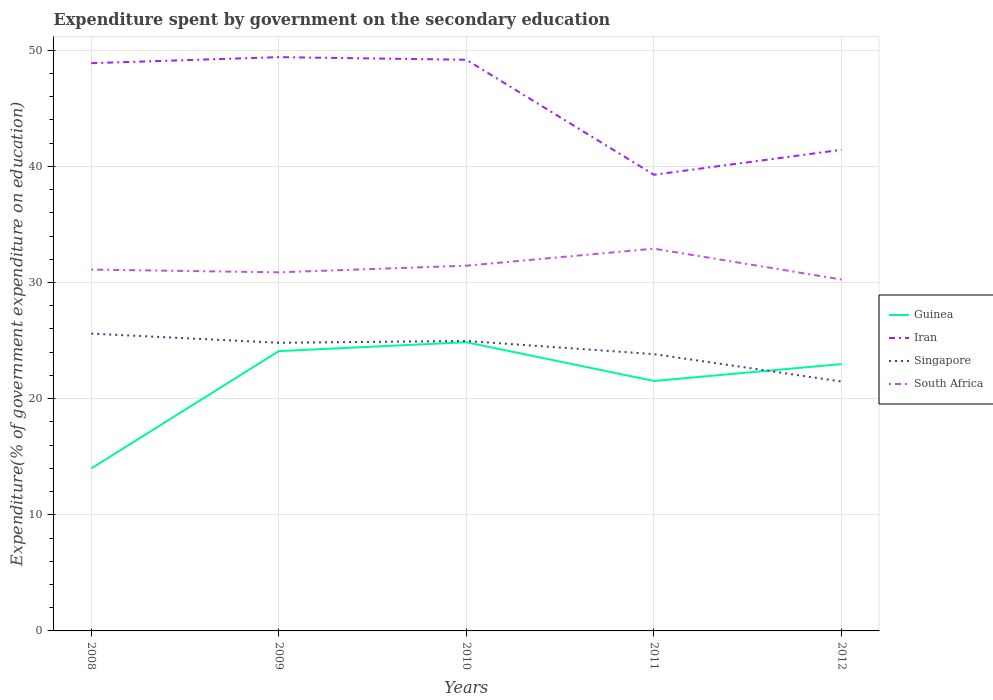How many different coloured lines are there?
Your response must be concise. 4. Across all years, what is the maximum expenditure spent by government on the secondary education in Iran?
Keep it short and to the point. 39.28. What is the total expenditure spent by government on the secondary education in Iran in the graph?
Provide a succinct answer. 0.23. What is the difference between the highest and the second highest expenditure spent by government on the secondary education in South Africa?
Provide a succinct answer. 2.66. What is the difference between the highest and the lowest expenditure spent by government on the secondary education in Guinea?
Provide a succinct answer. 4. Does the graph contain any zero values?
Your answer should be very brief. No. Does the graph contain grids?
Make the answer very short. Yes. Where does the legend appear in the graph?
Ensure brevity in your answer.  Center right. How many legend labels are there?
Offer a very short reply. 4. How are the legend labels stacked?
Give a very brief answer. Vertical. What is the title of the graph?
Offer a terse response. Expenditure spent by government on the secondary education. What is the label or title of the Y-axis?
Provide a short and direct response. Expenditure(% of government expenditure on education). What is the Expenditure(% of government expenditure on education) in Guinea in 2008?
Provide a succinct answer. 13.99. What is the Expenditure(% of government expenditure on education) in Iran in 2008?
Give a very brief answer. 48.89. What is the Expenditure(% of government expenditure on education) in Singapore in 2008?
Offer a terse response. 25.6. What is the Expenditure(% of government expenditure on education) in South Africa in 2008?
Make the answer very short. 31.12. What is the Expenditure(% of government expenditure on education) of Guinea in 2009?
Your answer should be very brief. 24.09. What is the Expenditure(% of government expenditure on education) in Iran in 2009?
Your answer should be very brief. 49.41. What is the Expenditure(% of government expenditure on education) of Singapore in 2009?
Your answer should be very brief. 24.81. What is the Expenditure(% of government expenditure on education) in South Africa in 2009?
Offer a terse response. 30.88. What is the Expenditure(% of government expenditure on education) of Guinea in 2010?
Your answer should be very brief. 24.86. What is the Expenditure(% of government expenditure on education) in Iran in 2010?
Keep it short and to the point. 49.18. What is the Expenditure(% of government expenditure on education) in Singapore in 2010?
Your response must be concise. 24.97. What is the Expenditure(% of government expenditure on education) of South Africa in 2010?
Ensure brevity in your answer.  31.45. What is the Expenditure(% of government expenditure on education) in Guinea in 2011?
Offer a terse response. 21.52. What is the Expenditure(% of government expenditure on education) of Iran in 2011?
Give a very brief answer. 39.28. What is the Expenditure(% of government expenditure on education) in Singapore in 2011?
Ensure brevity in your answer.  23.83. What is the Expenditure(% of government expenditure on education) in South Africa in 2011?
Give a very brief answer. 32.92. What is the Expenditure(% of government expenditure on education) of Guinea in 2012?
Your response must be concise. 22.98. What is the Expenditure(% of government expenditure on education) of Iran in 2012?
Offer a very short reply. 41.43. What is the Expenditure(% of government expenditure on education) of Singapore in 2012?
Ensure brevity in your answer.  21.47. What is the Expenditure(% of government expenditure on education) of South Africa in 2012?
Your answer should be compact. 30.26. Across all years, what is the maximum Expenditure(% of government expenditure on education) of Guinea?
Make the answer very short. 24.86. Across all years, what is the maximum Expenditure(% of government expenditure on education) in Iran?
Offer a terse response. 49.41. Across all years, what is the maximum Expenditure(% of government expenditure on education) in Singapore?
Keep it short and to the point. 25.6. Across all years, what is the maximum Expenditure(% of government expenditure on education) in South Africa?
Provide a succinct answer. 32.92. Across all years, what is the minimum Expenditure(% of government expenditure on education) in Guinea?
Provide a succinct answer. 13.99. Across all years, what is the minimum Expenditure(% of government expenditure on education) in Iran?
Provide a short and direct response. 39.28. Across all years, what is the minimum Expenditure(% of government expenditure on education) of Singapore?
Your response must be concise. 21.47. Across all years, what is the minimum Expenditure(% of government expenditure on education) of South Africa?
Your answer should be very brief. 30.26. What is the total Expenditure(% of government expenditure on education) of Guinea in the graph?
Provide a short and direct response. 107.44. What is the total Expenditure(% of government expenditure on education) in Iran in the graph?
Provide a succinct answer. 228.18. What is the total Expenditure(% of government expenditure on education) of Singapore in the graph?
Give a very brief answer. 120.69. What is the total Expenditure(% of government expenditure on education) in South Africa in the graph?
Ensure brevity in your answer.  156.62. What is the difference between the Expenditure(% of government expenditure on education) of Guinea in 2008 and that in 2009?
Your answer should be very brief. -10.1. What is the difference between the Expenditure(% of government expenditure on education) in Iran in 2008 and that in 2009?
Ensure brevity in your answer.  -0.52. What is the difference between the Expenditure(% of government expenditure on education) in Singapore in 2008 and that in 2009?
Offer a very short reply. 0.79. What is the difference between the Expenditure(% of government expenditure on education) in South Africa in 2008 and that in 2009?
Your answer should be very brief. 0.24. What is the difference between the Expenditure(% of government expenditure on education) of Guinea in 2008 and that in 2010?
Keep it short and to the point. -10.87. What is the difference between the Expenditure(% of government expenditure on education) of Iran in 2008 and that in 2010?
Make the answer very short. -0.3. What is the difference between the Expenditure(% of government expenditure on education) in Singapore in 2008 and that in 2010?
Give a very brief answer. 0.63. What is the difference between the Expenditure(% of government expenditure on education) of South Africa in 2008 and that in 2010?
Offer a very short reply. -0.33. What is the difference between the Expenditure(% of government expenditure on education) in Guinea in 2008 and that in 2011?
Your answer should be very brief. -7.53. What is the difference between the Expenditure(% of government expenditure on education) in Iran in 2008 and that in 2011?
Your answer should be very brief. 9.61. What is the difference between the Expenditure(% of government expenditure on education) of Singapore in 2008 and that in 2011?
Make the answer very short. 1.77. What is the difference between the Expenditure(% of government expenditure on education) in South Africa in 2008 and that in 2011?
Your response must be concise. -1.8. What is the difference between the Expenditure(% of government expenditure on education) of Guinea in 2008 and that in 2012?
Your answer should be compact. -8.99. What is the difference between the Expenditure(% of government expenditure on education) in Iran in 2008 and that in 2012?
Provide a short and direct response. 7.46. What is the difference between the Expenditure(% of government expenditure on education) of Singapore in 2008 and that in 2012?
Make the answer very short. 4.13. What is the difference between the Expenditure(% of government expenditure on education) in South Africa in 2008 and that in 2012?
Your response must be concise. 0.86. What is the difference between the Expenditure(% of government expenditure on education) of Guinea in 2009 and that in 2010?
Make the answer very short. -0.76. What is the difference between the Expenditure(% of government expenditure on education) of Iran in 2009 and that in 2010?
Provide a short and direct response. 0.23. What is the difference between the Expenditure(% of government expenditure on education) of Singapore in 2009 and that in 2010?
Ensure brevity in your answer.  -0.16. What is the difference between the Expenditure(% of government expenditure on education) in South Africa in 2009 and that in 2010?
Make the answer very short. -0.57. What is the difference between the Expenditure(% of government expenditure on education) in Guinea in 2009 and that in 2011?
Provide a short and direct response. 2.57. What is the difference between the Expenditure(% of government expenditure on education) in Iran in 2009 and that in 2011?
Provide a succinct answer. 10.13. What is the difference between the Expenditure(% of government expenditure on education) of Singapore in 2009 and that in 2011?
Keep it short and to the point. 0.98. What is the difference between the Expenditure(% of government expenditure on education) of South Africa in 2009 and that in 2011?
Ensure brevity in your answer.  -2.04. What is the difference between the Expenditure(% of government expenditure on education) in Guinea in 2009 and that in 2012?
Offer a very short reply. 1.12. What is the difference between the Expenditure(% of government expenditure on education) in Iran in 2009 and that in 2012?
Provide a succinct answer. 7.98. What is the difference between the Expenditure(% of government expenditure on education) of Singapore in 2009 and that in 2012?
Your answer should be compact. 3.34. What is the difference between the Expenditure(% of government expenditure on education) in South Africa in 2009 and that in 2012?
Your answer should be very brief. 0.62. What is the difference between the Expenditure(% of government expenditure on education) in Guinea in 2010 and that in 2011?
Ensure brevity in your answer.  3.33. What is the difference between the Expenditure(% of government expenditure on education) in Iran in 2010 and that in 2011?
Offer a very short reply. 9.9. What is the difference between the Expenditure(% of government expenditure on education) of Singapore in 2010 and that in 2011?
Your answer should be compact. 1.13. What is the difference between the Expenditure(% of government expenditure on education) of South Africa in 2010 and that in 2011?
Provide a short and direct response. -1.47. What is the difference between the Expenditure(% of government expenditure on education) of Guinea in 2010 and that in 2012?
Ensure brevity in your answer.  1.88. What is the difference between the Expenditure(% of government expenditure on education) of Iran in 2010 and that in 2012?
Your answer should be very brief. 7.75. What is the difference between the Expenditure(% of government expenditure on education) of Singapore in 2010 and that in 2012?
Offer a terse response. 3.49. What is the difference between the Expenditure(% of government expenditure on education) of South Africa in 2010 and that in 2012?
Ensure brevity in your answer.  1.19. What is the difference between the Expenditure(% of government expenditure on education) in Guinea in 2011 and that in 2012?
Give a very brief answer. -1.45. What is the difference between the Expenditure(% of government expenditure on education) in Iran in 2011 and that in 2012?
Give a very brief answer. -2.15. What is the difference between the Expenditure(% of government expenditure on education) in Singapore in 2011 and that in 2012?
Ensure brevity in your answer.  2.36. What is the difference between the Expenditure(% of government expenditure on education) of South Africa in 2011 and that in 2012?
Offer a very short reply. 2.66. What is the difference between the Expenditure(% of government expenditure on education) of Guinea in 2008 and the Expenditure(% of government expenditure on education) of Iran in 2009?
Provide a short and direct response. -35.42. What is the difference between the Expenditure(% of government expenditure on education) in Guinea in 2008 and the Expenditure(% of government expenditure on education) in Singapore in 2009?
Give a very brief answer. -10.82. What is the difference between the Expenditure(% of government expenditure on education) in Guinea in 2008 and the Expenditure(% of government expenditure on education) in South Africa in 2009?
Give a very brief answer. -16.89. What is the difference between the Expenditure(% of government expenditure on education) in Iran in 2008 and the Expenditure(% of government expenditure on education) in Singapore in 2009?
Your answer should be compact. 24.07. What is the difference between the Expenditure(% of government expenditure on education) in Iran in 2008 and the Expenditure(% of government expenditure on education) in South Africa in 2009?
Provide a short and direct response. 18.01. What is the difference between the Expenditure(% of government expenditure on education) of Singapore in 2008 and the Expenditure(% of government expenditure on education) of South Africa in 2009?
Keep it short and to the point. -5.28. What is the difference between the Expenditure(% of government expenditure on education) in Guinea in 2008 and the Expenditure(% of government expenditure on education) in Iran in 2010?
Your answer should be compact. -35.19. What is the difference between the Expenditure(% of government expenditure on education) in Guinea in 2008 and the Expenditure(% of government expenditure on education) in Singapore in 2010?
Provide a succinct answer. -10.98. What is the difference between the Expenditure(% of government expenditure on education) in Guinea in 2008 and the Expenditure(% of government expenditure on education) in South Africa in 2010?
Offer a terse response. -17.46. What is the difference between the Expenditure(% of government expenditure on education) of Iran in 2008 and the Expenditure(% of government expenditure on education) of Singapore in 2010?
Offer a very short reply. 23.92. What is the difference between the Expenditure(% of government expenditure on education) of Iran in 2008 and the Expenditure(% of government expenditure on education) of South Africa in 2010?
Ensure brevity in your answer.  17.44. What is the difference between the Expenditure(% of government expenditure on education) of Singapore in 2008 and the Expenditure(% of government expenditure on education) of South Africa in 2010?
Your answer should be very brief. -5.85. What is the difference between the Expenditure(% of government expenditure on education) in Guinea in 2008 and the Expenditure(% of government expenditure on education) in Iran in 2011?
Offer a very short reply. -25.29. What is the difference between the Expenditure(% of government expenditure on education) of Guinea in 2008 and the Expenditure(% of government expenditure on education) of Singapore in 2011?
Provide a succinct answer. -9.84. What is the difference between the Expenditure(% of government expenditure on education) in Guinea in 2008 and the Expenditure(% of government expenditure on education) in South Africa in 2011?
Make the answer very short. -18.93. What is the difference between the Expenditure(% of government expenditure on education) in Iran in 2008 and the Expenditure(% of government expenditure on education) in Singapore in 2011?
Your response must be concise. 25.05. What is the difference between the Expenditure(% of government expenditure on education) in Iran in 2008 and the Expenditure(% of government expenditure on education) in South Africa in 2011?
Offer a very short reply. 15.97. What is the difference between the Expenditure(% of government expenditure on education) in Singapore in 2008 and the Expenditure(% of government expenditure on education) in South Africa in 2011?
Ensure brevity in your answer.  -7.32. What is the difference between the Expenditure(% of government expenditure on education) of Guinea in 2008 and the Expenditure(% of government expenditure on education) of Iran in 2012?
Keep it short and to the point. -27.44. What is the difference between the Expenditure(% of government expenditure on education) in Guinea in 2008 and the Expenditure(% of government expenditure on education) in Singapore in 2012?
Keep it short and to the point. -7.48. What is the difference between the Expenditure(% of government expenditure on education) in Guinea in 2008 and the Expenditure(% of government expenditure on education) in South Africa in 2012?
Provide a succinct answer. -16.27. What is the difference between the Expenditure(% of government expenditure on education) of Iran in 2008 and the Expenditure(% of government expenditure on education) of Singapore in 2012?
Your answer should be compact. 27.41. What is the difference between the Expenditure(% of government expenditure on education) in Iran in 2008 and the Expenditure(% of government expenditure on education) in South Africa in 2012?
Make the answer very short. 18.63. What is the difference between the Expenditure(% of government expenditure on education) of Singapore in 2008 and the Expenditure(% of government expenditure on education) of South Africa in 2012?
Your answer should be compact. -4.66. What is the difference between the Expenditure(% of government expenditure on education) in Guinea in 2009 and the Expenditure(% of government expenditure on education) in Iran in 2010?
Provide a succinct answer. -25.09. What is the difference between the Expenditure(% of government expenditure on education) in Guinea in 2009 and the Expenditure(% of government expenditure on education) in Singapore in 2010?
Give a very brief answer. -0.87. What is the difference between the Expenditure(% of government expenditure on education) of Guinea in 2009 and the Expenditure(% of government expenditure on education) of South Africa in 2010?
Your answer should be very brief. -7.36. What is the difference between the Expenditure(% of government expenditure on education) of Iran in 2009 and the Expenditure(% of government expenditure on education) of Singapore in 2010?
Your answer should be compact. 24.44. What is the difference between the Expenditure(% of government expenditure on education) of Iran in 2009 and the Expenditure(% of government expenditure on education) of South Africa in 2010?
Offer a very short reply. 17.96. What is the difference between the Expenditure(% of government expenditure on education) of Singapore in 2009 and the Expenditure(% of government expenditure on education) of South Africa in 2010?
Your response must be concise. -6.64. What is the difference between the Expenditure(% of government expenditure on education) of Guinea in 2009 and the Expenditure(% of government expenditure on education) of Iran in 2011?
Provide a succinct answer. -15.18. What is the difference between the Expenditure(% of government expenditure on education) of Guinea in 2009 and the Expenditure(% of government expenditure on education) of Singapore in 2011?
Your answer should be compact. 0.26. What is the difference between the Expenditure(% of government expenditure on education) of Guinea in 2009 and the Expenditure(% of government expenditure on education) of South Africa in 2011?
Give a very brief answer. -8.82. What is the difference between the Expenditure(% of government expenditure on education) in Iran in 2009 and the Expenditure(% of government expenditure on education) in Singapore in 2011?
Offer a very short reply. 25.57. What is the difference between the Expenditure(% of government expenditure on education) in Iran in 2009 and the Expenditure(% of government expenditure on education) in South Africa in 2011?
Your response must be concise. 16.49. What is the difference between the Expenditure(% of government expenditure on education) of Singapore in 2009 and the Expenditure(% of government expenditure on education) of South Africa in 2011?
Make the answer very short. -8.1. What is the difference between the Expenditure(% of government expenditure on education) in Guinea in 2009 and the Expenditure(% of government expenditure on education) in Iran in 2012?
Provide a succinct answer. -17.33. What is the difference between the Expenditure(% of government expenditure on education) of Guinea in 2009 and the Expenditure(% of government expenditure on education) of Singapore in 2012?
Ensure brevity in your answer.  2.62. What is the difference between the Expenditure(% of government expenditure on education) of Guinea in 2009 and the Expenditure(% of government expenditure on education) of South Africa in 2012?
Ensure brevity in your answer.  -6.16. What is the difference between the Expenditure(% of government expenditure on education) in Iran in 2009 and the Expenditure(% of government expenditure on education) in Singapore in 2012?
Make the answer very short. 27.93. What is the difference between the Expenditure(% of government expenditure on education) in Iran in 2009 and the Expenditure(% of government expenditure on education) in South Africa in 2012?
Provide a short and direct response. 19.15. What is the difference between the Expenditure(% of government expenditure on education) in Singapore in 2009 and the Expenditure(% of government expenditure on education) in South Africa in 2012?
Make the answer very short. -5.44. What is the difference between the Expenditure(% of government expenditure on education) in Guinea in 2010 and the Expenditure(% of government expenditure on education) in Iran in 2011?
Offer a very short reply. -14.42. What is the difference between the Expenditure(% of government expenditure on education) of Guinea in 2010 and the Expenditure(% of government expenditure on education) of Singapore in 2011?
Ensure brevity in your answer.  1.02. What is the difference between the Expenditure(% of government expenditure on education) in Guinea in 2010 and the Expenditure(% of government expenditure on education) in South Africa in 2011?
Your answer should be very brief. -8.06. What is the difference between the Expenditure(% of government expenditure on education) in Iran in 2010 and the Expenditure(% of government expenditure on education) in Singapore in 2011?
Make the answer very short. 25.35. What is the difference between the Expenditure(% of government expenditure on education) in Iran in 2010 and the Expenditure(% of government expenditure on education) in South Africa in 2011?
Your answer should be compact. 16.27. What is the difference between the Expenditure(% of government expenditure on education) in Singapore in 2010 and the Expenditure(% of government expenditure on education) in South Africa in 2011?
Offer a terse response. -7.95. What is the difference between the Expenditure(% of government expenditure on education) of Guinea in 2010 and the Expenditure(% of government expenditure on education) of Iran in 2012?
Ensure brevity in your answer.  -16.57. What is the difference between the Expenditure(% of government expenditure on education) in Guinea in 2010 and the Expenditure(% of government expenditure on education) in Singapore in 2012?
Keep it short and to the point. 3.38. What is the difference between the Expenditure(% of government expenditure on education) in Guinea in 2010 and the Expenditure(% of government expenditure on education) in South Africa in 2012?
Ensure brevity in your answer.  -5.4. What is the difference between the Expenditure(% of government expenditure on education) of Iran in 2010 and the Expenditure(% of government expenditure on education) of Singapore in 2012?
Give a very brief answer. 27.71. What is the difference between the Expenditure(% of government expenditure on education) of Iran in 2010 and the Expenditure(% of government expenditure on education) of South Africa in 2012?
Keep it short and to the point. 18.93. What is the difference between the Expenditure(% of government expenditure on education) of Singapore in 2010 and the Expenditure(% of government expenditure on education) of South Africa in 2012?
Provide a short and direct response. -5.29. What is the difference between the Expenditure(% of government expenditure on education) of Guinea in 2011 and the Expenditure(% of government expenditure on education) of Iran in 2012?
Ensure brevity in your answer.  -19.9. What is the difference between the Expenditure(% of government expenditure on education) of Guinea in 2011 and the Expenditure(% of government expenditure on education) of Singapore in 2012?
Ensure brevity in your answer.  0.05. What is the difference between the Expenditure(% of government expenditure on education) in Guinea in 2011 and the Expenditure(% of government expenditure on education) in South Africa in 2012?
Offer a very short reply. -8.73. What is the difference between the Expenditure(% of government expenditure on education) of Iran in 2011 and the Expenditure(% of government expenditure on education) of Singapore in 2012?
Your answer should be very brief. 17.81. What is the difference between the Expenditure(% of government expenditure on education) in Iran in 2011 and the Expenditure(% of government expenditure on education) in South Africa in 2012?
Your answer should be compact. 9.02. What is the difference between the Expenditure(% of government expenditure on education) of Singapore in 2011 and the Expenditure(% of government expenditure on education) of South Africa in 2012?
Your answer should be very brief. -6.42. What is the average Expenditure(% of government expenditure on education) in Guinea per year?
Offer a terse response. 21.49. What is the average Expenditure(% of government expenditure on education) of Iran per year?
Your response must be concise. 45.64. What is the average Expenditure(% of government expenditure on education) in Singapore per year?
Make the answer very short. 24.14. What is the average Expenditure(% of government expenditure on education) of South Africa per year?
Give a very brief answer. 31.32. In the year 2008, what is the difference between the Expenditure(% of government expenditure on education) of Guinea and Expenditure(% of government expenditure on education) of Iran?
Your answer should be very brief. -34.9. In the year 2008, what is the difference between the Expenditure(% of government expenditure on education) in Guinea and Expenditure(% of government expenditure on education) in Singapore?
Keep it short and to the point. -11.61. In the year 2008, what is the difference between the Expenditure(% of government expenditure on education) in Guinea and Expenditure(% of government expenditure on education) in South Africa?
Make the answer very short. -17.13. In the year 2008, what is the difference between the Expenditure(% of government expenditure on education) of Iran and Expenditure(% of government expenditure on education) of Singapore?
Offer a very short reply. 23.29. In the year 2008, what is the difference between the Expenditure(% of government expenditure on education) in Iran and Expenditure(% of government expenditure on education) in South Africa?
Make the answer very short. 17.77. In the year 2008, what is the difference between the Expenditure(% of government expenditure on education) in Singapore and Expenditure(% of government expenditure on education) in South Africa?
Ensure brevity in your answer.  -5.52. In the year 2009, what is the difference between the Expenditure(% of government expenditure on education) in Guinea and Expenditure(% of government expenditure on education) in Iran?
Offer a terse response. -25.31. In the year 2009, what is the difference between the Expenditure(% of government expenditure on education) of Guinea and Expenditure(% of government expenditure on education) of Singapore?
Offer a terse response. -0.72. In the year 2009, what is the difference between the Expenditure(% of government expenditure on education) of Guinea and Expenditure(% of government expenditure on education) of South Africa?
Offer a terse response. -6.78. In the year 2009, what is the difference between the Expenditure(% of government expenditure on education) in Iran and Expenditure(% of government expenditure on education) in Singapore?
Your response must be concise. 24.6. In the year 2009, what is the difference between the Expenditure(% of government expenditure on education) in Iran and Expenditure(% of government expenditure on education) in South Africa?
Your answer should be compact. 18.53. In the year 2009, what is the difference between the Expenditure(% of government expenditure on education) of Singapore and Expenditure(% of government expenditure on education) of South Africa?
Ensure brevity in your answer.  -6.07. In the year 2010, what is the difference between the Expenditure(% of government expenditure on education) of Guinea and Expenditure(% of government expenditure on education) of Iran?
Ensure brevity in your answer.  -24.32. In the year 2010, what is the difference between the Expenditure(% of government expenditure on education) of Guinea and Expenditure(% of government expenditure on education) of Singapore?
Offer a very short reply. -0.11. In the year 2010, what is the difference between the Expenditure(% of government expenditure on education) of Guinea and Expenditure(% of government expenditure on education) of South Africa?
Give a very brief answer. -6.59. In the year 2010, what is the difference between the Expenditure(% of government expenditure on education) of Iran and Expenditure(% of government expenditure on education) of Singapore?
Provide a succinct answer. 24.21. In the year 2010, what is the difference between the Expenditure(% of government expenditure on education) of Iran and Expenditure(% of government expenditure on education) of South Africa?
Keep it short and to the point. 17.73. In the year 2010, what is the difference between the Expenditure(% of government expenditure on education) in Singapore and Expenditure(% of government expenditure on education) in South Africa?
Provide a short and direct response. -6.48. In the year 2011, what is the difference between the Expenditure(% of government expenditure on education) of Guinea and Expenditure(% of government expenditure on education) of Iran?
Give a very brief answer. -17.76. In the year 2011, what is the difference between the Expenditure(% of government expenditure on education) in Guinea and Expenditure(% of government expenditure on education) in Singapore?
Offer a very short reply. -2.31. In the year 2011, what is the difference between the Expenditure(% of government expenditure on education) in Guinea and Expenditure(% of government expenditure on education) in South Africa?
Provide a succinct answer. -11.39. In the year 2011, what is the difference between the Expenditure(% of government expenditure on education) in Iran and Expenditure(% of government expenditure on education) in Singapore?
Your answer should be very brief. 15.44. In the year 2011, what is the difference between the Expenditure(% of government expenditure on education) of Iran and Expenditure(% of government expenditure on education) of South Africa?
Your answer should be compact. 6.36. In the year 2011, what is the difference between the Expenditure(% of government expenditure on education) in Singapore and Expenditure(% of government expenditure on education) in South Africa?
Offer a very short reply. -9.08. In the year 2012, what is the difference between the Expenditure(% of government expenditure on education) in Guinea and Expenditure(% of government expenditure on education) in Iran?
Keep it short and to the point. -18.45. In the year 2012, what is the difference between the Expenditure(% of government expenditure on education) in Guinea and Expenditure(% of government expenditure on education) in Singapore?
Give a very brief answer. 1.5. In the year 2012, what is the difference between the Expenditure(% of government expenditure on education) in Guinea and Expenditure(% of government expenditure on education) in South Africa?
Ensure brevity in your answer.  -7.28. In the year 2012, what is the difference between the Expenditure(% of government expenditure on education) of Iran and Expenditure(% of government expenditure on education) of Singapore?
Offer a very short reply. 19.95. In the year 2012, what is the difference between the Expenditure(% of government expenditure on education) in Iran and Expenditure(% of government expenditure on education) in South Africa?
Give a very brief answer. 11.17. In the year 2012, what is the difference between the Expenditure(% of government expenditure on education) of Singapore and Expenditure(% of government expenditure on education) of South Africa?
Offer a terse response. -8.78. What is the ratio of the Expenditure(% of government expenditure on education) in Guinea in 2008 to that in 2009?
Provide a succinct answer. 0.58. What is the ratio of the Expenditure(% of government expenditure on education) in Iran in 2008 to that in 2009?
Provide a succinct answer. 0.99. What is the ratio of the Expenditure(% of government expenditure on education) of Singapore in 2008 to that in 2009?
Provide a short and direct response. 1.03. What is the ratio of the Expenditure(% of government expenditure on education) of South Africa in 2008 to that in 2009?
Provide a succinct answer. 1.01. What is the ratio of the Expenditure(% of government expenditure on education) of Guinea in 2008 to that in 2010?
Ensure brevity in your answer.  0.56. What is the ratio of the Expenditure(% of government expenditure on education) in Singapore in 2008 to that in 2010?
Keep it short and to the point. 1.03. What is the ratio of the Expenditure(% of government expenditure on education) of South Africa in 2008 to that in 2010?
Your answer should be very brief. 0.99. What is the ratio of the Expenditure(% of government expenditure on education) in Guinea in 2008 to that in 2011?
Provide a short and direct response. 0.65. What is the ratio of the Expenditure(% of government expenditure on education) of Iran in 2008 to that in 2011?
Your answer should be very brief. 1.24. What is the ratio of the Expenditure(% of government expenditure on education) in Singapore in 2008 to that in 2011?
Keep it short and to the point. 1.07. What is the ratio of the Expenditure(% of government expenditure on education) in South Africa in 2008 to that in 2011?
Make the answer very short. 0.95. What is the ratio of the Expenditure(% of government expenditure on education) in Guinea in 2008 to that in 2012?
Your answer should be compact. 0.61. What is the ratio of the Expenditure(% of government expenditure on education) of Iran in 2008 to that in 2012?
Your response must be concise. 1.18. What is the ratio of the Expenditure(% of government expenditure on education) in Singapore in 2008 to that in 2012?
Keep it short and to the point. 1.19. What is the ratio of the Expenditure(% of government expenditure on education) of South Africa in 2008 to that in 2012?
Give a very brief answer. 1.03. What is the ratio of the Expenditure(% of government expenditure on education) of Guinea in 2009 to that in 2010?
Provide a short and direct response. 0.97. What is the ratio of the Expenditure(% of government expenditure on education) of Iran in 2009 to that in 2010?
Provide a short and direct response. 1. What is the ratio of the Expenditure(% of government expenditure on education) in South Africa in 2009 to that in 2010?
Your response must be concise. 0.98. What is the ratio of the Expenditure(% of government expenditure on education) in Guinea in 2009 to that in 2011?
Offer a very short reply. 1.12. What is the ratio of the Expenditure(% of government expenditure on education) in Iran in 2009 to that in 2011?
Offer a terse response. 1.26. What is the ratio of the Expenditure(% of government expenditure on education) of Singapore in 2009 to that in 2011?
Provide a succinct answer. 1.04. What is the ratio of the Expenditure(% of government expenditure on education) in South Africa in 2009 to that in 2011?
Ensure brevity in your answer.  0.94. What is the ratio of the Expenditure(% of government expenditure on education) of Guinea in 2009 to that in 2012?
Provide a succinct answer. 1.05. What is the ratio of the Expenditure(% of government expenditure on education) of Iran in 2009 to that in 2012?
Give a very brief answer. 1.19. What is the ratio of the Expenditure(% of government expenditure on education) in Singapore in 2009 to that in 2012?
Provide a short and direct response. 1.16. What is the ratio of the Expenditure(% of government expenditure on education) in South Africa in 2009 to that in 2012?
Provide a short and direct response. 1.02. What is the ratio of the Expenditure(% of government expenditure on education) of Guinea in 2010 to that in 2011?
Ensure brevity in your answer.  1.15. What is the ratio of the Expenditure(% of government expenditure on education) of Iran in 2010 to that in 2011?
Your response must be concise. 1.25. What is the ratio of the Expenditure(% of government expenditure on education) in Singapore in 2010 to that in 2011?
Your answer should be very brief. 1.05. What is the ratio of the Expenditure(% of government expenditure on education) in South Africa in 2010 to that in 2011?
Keep it short and to the point. 0.96. What is the ratio of the Expenditure(% of government expenditure on education) of Guinea in 2010 to that in 2012?
Provide a succinct answer. 1.08. What is the ratio of the Expenditure(% of government expenditure on education) in Iran in 2010 to that in 2012?
Your answer should be compact. 1.19. What is the ratio of the Expenditure(% of government expenditure on education) in Singapore in 2010 to that in 2012?
Your answer should be very brief. 1.16. What is the ratio of the Expenditure(% of government expenditure on education) in South Africa in 2010 to that in 2012?
Offer a terse response. 1.04. What is the ratio of the Expenditure(% of government expenditure on education) in Guinea in 2011 to that in 2012?
Make the answer very short. 0.94. What is the ratio of the Expenditure(% of government expenditure on education) of Iran in 2011 to that in 2012?
Provide a short and direct response. 0.95. What is the ratio of the Expenditure(% of government expenditure on education) of Singapore in 2011 to that in 2012?
Ensure brevity in your answer.  1.11. What is the ratio of the Expenditure(% of government expenditure on education) of South Africa in 2011 to that in 2012?
Offer a terse response. 1.09. What is the difference between the highest and the second highest Expenditure(% of government expenditure on education) of Guinea?
Keep it short and to the point. 0.76. What is the difference between the highest and the second highest Expenditure(% of government expenditure on education) in Iran?
Provide a succinct answer. 0.23. What is the difference between the highest and the second highest Expenditure(% of government expenditure on education) of Singapore?
Make the answer very short. 0.63. What is the difference between the highest and the second highest Expenditure(% of government expenditure on education) of South Africa?
Your answer should be very brief. 1.47. What is the difference between the highest and the lowest Expenditure(% of government expenditure on education) of Guinea?
Your response must be concise. 10.87. What is the difference between the highest and the lowest Expenditure(% of government expenditure on education) in Iran?
Provide a succinct answer. 10.13. What is the difference between the highest and the lowest Expenditure(% of government expenditure on education) of Singapore?
Provide a succinct answer. 4.13. What is the difference between the highest and the lowest Expenditure(% of government expenditure on education) in South Africa?
Give a very brief answer. 2.66. 